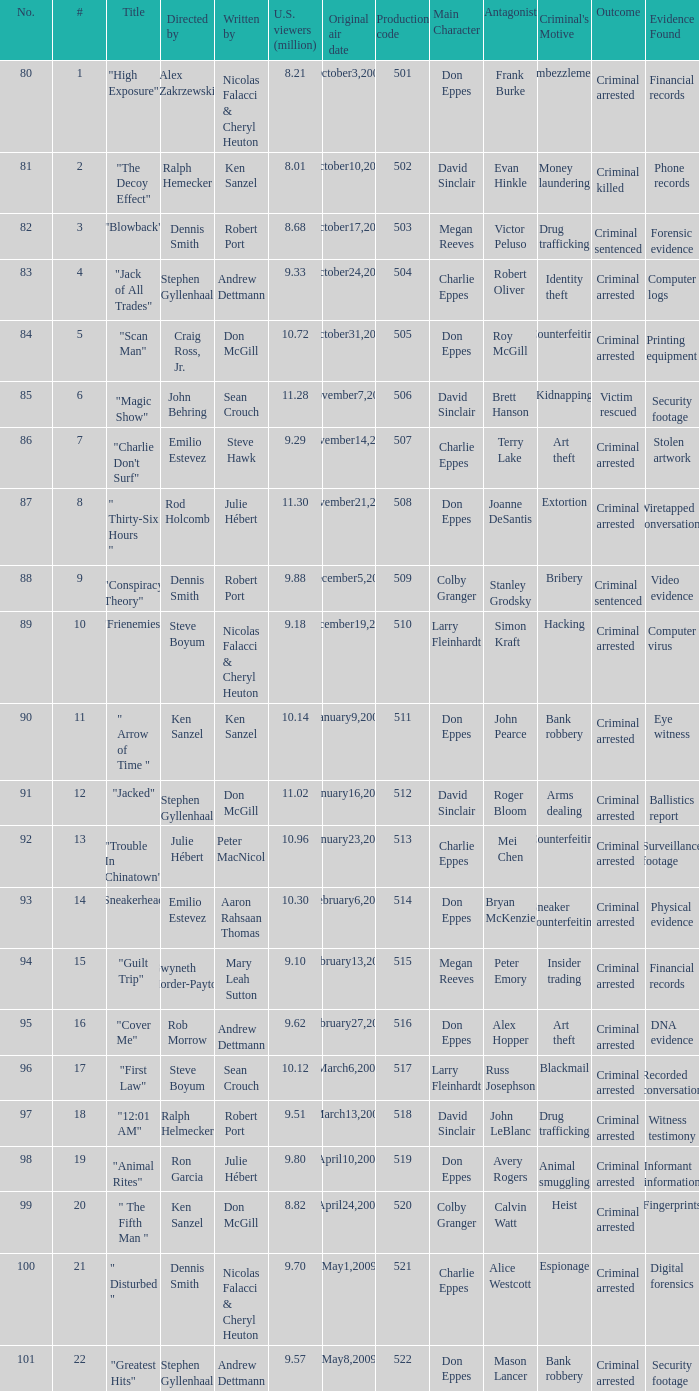What is the production code for the episode that had 9.18 million viewers (U.S.)? 510.0. 